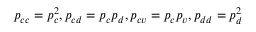<formula> <loc_0><loc_0><loc_500><loc_500>p _ { c c } = p _ { c } ^ { 2 } , p _ { c d } = p _ { c } p _ { d } , p _ { c v } = p _ { c } p _ { v } , p _ { d d } = p _ { d } ^ { 2 }</formula> 